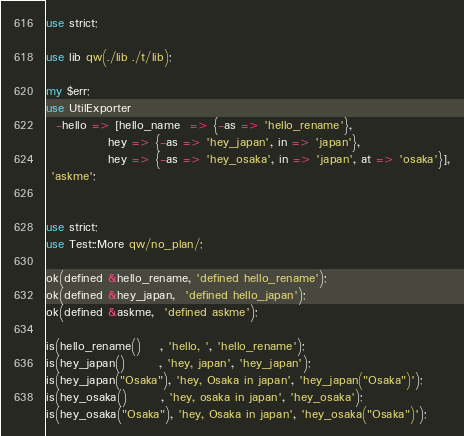<code> <loc_0><loc_0><loc_500><loc_500><_Perl_>use strict;

use lib qw(./lib ./t/lib);

my $err;
use UtilExporter
  -hello => [hello_name  => {-as => 'hello_rename'},
             hey => {-as => 'hey_japan', in => 'japan'},
             hey => {-as => 'hey_osaka', in => 'japan', at => 'osaka'}],
 'askme';


use strict;
use Test::More qw/no_plan/;

ok(defined &hello_rename, 'defined hello_rename');
ok(defined &hey_japan,  'defined hello_japan');
ok(defined &askme,  'defined askme');

is(hello_rename()    , 'hello, ', 'hello_rename');
is(hey_japan()       , 'hey, japan', 'hey_japan');
is(hey_japan("Osaka"), 'hey, Osaka in japan', 'hey_japan("Osaka")');
is(hey_osaka()       , 'hey, osaka in japan', 'hey_osaka');
is(hey_osaka("Osaka"), 'hey, Osaka in japan', 'hey_osaka("Osaka")');
</code> 